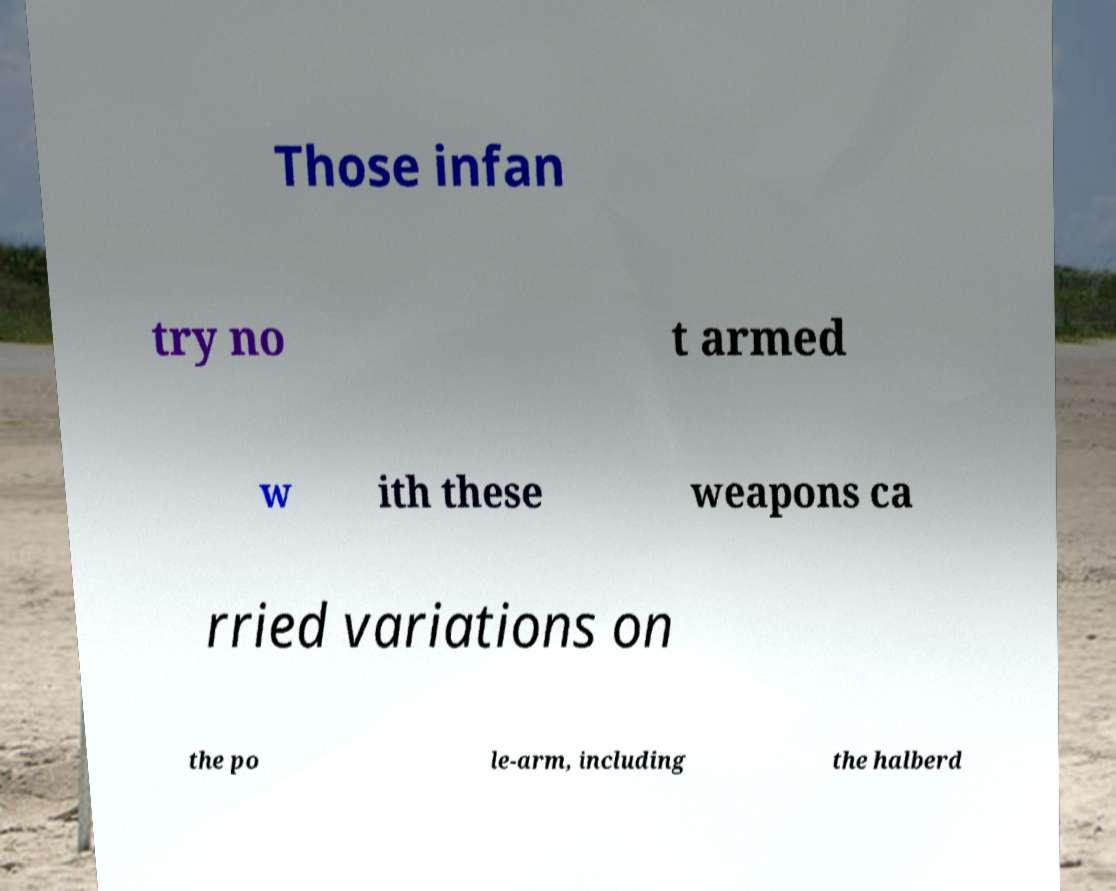For documentation purposes, I need the text within this image transcribed. Could you provide that? Those infan try no t armed w ith these weapons ca rried variations on the po le-arm, including the halberd 